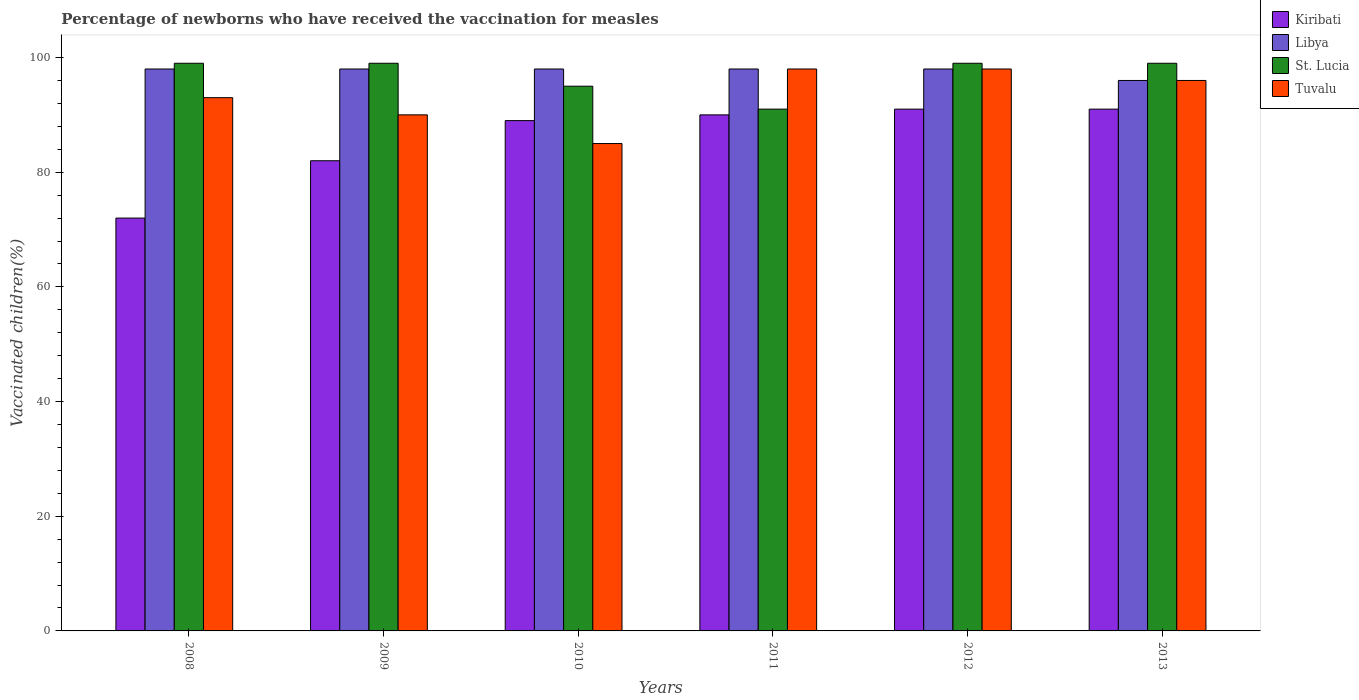How many groups of bars are there?
Provide a short and direct response. 6. How many bars are there on the 5th tick from the left?
Offer a terse response. 4. In how many cases, is the number of bars for a given year not equal to the number of legend labels?
Offer a very short reply. 0. What is the percentage of vaccinated children in St. Lucia in 2011?
Offer a very short reply. 91. Across all years, what is the maximum percentage of vaccinated children in Kiribati?
Provide a short and direct response. 91. In which year was the percentage of vaccinated children in Tuvalu maximum?
Offer a very short reply. 2011. In which year was the percentage of vaccinated children in Libya minimum?
Offer a terse response. 2013. What is the total percentage of vaccinated children in Libya in the graph?
Ensure brevity in your answer.  586. What is the difference between the percentage of vaccinated children in Tuvalu in 2010 and that in 2013?
Your answer should be compact. -11. What is the average percentage of vaccinated children in St. Lucia per year?
Your answer should be compact. 97. What is the ratio of the percentage of vaccinated children in Tuvalu in 2010 to that in 2011?
Keep it short and to the point. 0.87. Is the difference between the percentage of vaccinated children in Libya in 2009 and 2012 greater than the difference between the percentage of vaccinated children in Tuvalu in 2009 and 2012?
Ensure brevity in your answer.  Yes. Is the sum of the percentage of vaccinated children in Kiribati in 2010 and 2012 greater than the maximum percentage of vaccinated children in Libya across all years?
Provide a succinct answer. Yes. Is it the case that in every year, the sum of the percentage of vaccinated children in Tuvalu and percentage of vaccinated children in Kiribati is greater than the sum of percentage of vaccinated children in St. Lucia and percentage of vaccinated children in Libya?
Offer a terse response. No. What does the 3rd bar from the left in 2009 represents?
Your answer should be very brief. St. Lucia. What does the 4th bar from the right in 2011 represents?
Your answer should be very brief. Kiribati. How many bars are there?
Your answer should be very brief. 24. Are all the bars in the graph horizontal?
Make the answer very short. No. How many years are there in the graph?
Keep it short and to the point. 6. What is the difference between two consecutive major ticks on the Y-axis?
Your answer should be very brief. 20. Does the graph contain grids?
Make the answer very short. No. Where does the legend appear in the graph?
Your answer should be compact. Top right. How are the legend labels stacked?
Offer a very short reply. Vertical. What is the title of the graph?
Your answer should be compact. Percentage of newborns who have received the vaccination for measles. What is the label or title of the Y-axis?
Provide a succinct answer. Vaccinated children(%). What is the Vaccinated children(%) of Tuvalu in 2008?
Give a very brief answer. 93. What is the Vaccinated children(%) of Kiribati in 2010?
Offer a terse response. 89. What is the Vaccinated children(%) of St. Lucia in 2010?
Provide a succinct answer. 95. What is the Vaccinated children(%) of Tuvalu in 2010?
Keep it short and to the point. 85. What is the Vaccinated children(%) of Kiribati in 2011?
Make the answer very short. 90. What is the Vaccinated children(%) in Libya in 2011?
Your answer should be compact. 98. What is the Vaccinated children(%) in St. Lucia in 2011?
Offer a very short reply. 91. What is the Vaccinated children(%) in Tuvalu in 2011?
Make the answer very short. 98. What is the Vaccinated children(%) of Kiribati in 2012?
Your answer should be very brief. 91. What is the Vaccinated children(%) in St. Lucia in 2012?
Provide a short and direct response. 99. What is the Vaccinated children(%) in Kiribati in 2013?
Offer a very short reply. 91. What is the Vaccinated children(%) in Libya in 2013?
Your response must be concise. 96. What is the Vaccinated children(%) in Tuvalu in 2013?
Your answer should be very brief. 96. Across all years, what is the maximum Vaccinated children(%) of Kiribati?
Provide a short and direct response. 91. Across all years, what is the maximum Vaccinated children(%) in Libya?
Your answer should be very brief. 98. Across all years, what is the maximum Vaccinated children(%) in Tuvalu?
Keep it short and to the point. 98. Across all years, what is the minimum Vaccinated children(%) of Kiribati?
Offer a terse response. 72. Across all years, what is the minimum Vaccinated children(%) in Libya?
Offer a very short reply. 96. Across all years, what is the minimum Vaccinated children(%) of St. Lucia?
Ensure brevity in your answer.  91. Across all years, what is the minimum Vaccinated children(%) in Tuvalu?
Keep it short and to the point. 85. What is the total Vaccinated children(%) in Kiribati in the graph?
Provide a short and direct response. 515. What is the total Vaccinated children(%) of Libya in the graph?
Your response must be concise. 586. What is the total Vaccinated children(%) of St. Lucia in the graph?
Make the answer very short. 582. What is the total Vaccinated children(%) in Tuvalu in the graph?
Make the answer very short. 560. What is the difference between the Vaccinated children(%) in Libya in 2008 and that in 2009?
Provide a succinct answer. 0. What is the difference between the Vaccinated children(%) in St. Lucia in 2008 and that in 2009?
Offer a terse response. 0. What is the difference between the Vaccinated children(%) of Tuvalu in 2008 and that in 2009?
Offer a very short reply. 3. What is the difference between the Vaccinated children(%) of Kiribati in 2008 and that in 2010?
Give a very brief answer. -17. What is the difference between the Vaccinated children(%) in Tuvalu in 2008 and that in 2010?
Give a very brief answer. 8. What is the difference between the Vaccinated children(%) of Kiribati in 2008 and that in 2011?
Offer a very short reply. -18. What is the difference between the Vaccinated children(%) of St. Lucia in 2008 and that in 2011?
Your response must be concise. 8. What is the difference between the Vaccinated children(%) in Kiribati in 2008 and that in 2012?
Ensure brevity in your answer.  -19. What is the difference between the Vaccinated children(%) of Libya in 2008 and that in 2012?
Make the answer very short. 0. What is the difference between the Vaccinated children(%) of Tuvalu in 2008 and that in 2012?
Offer a terse response. -5. What is the difference between the Vaccinated children(%) in Kiribati in 2008 and that in 2013?
Offer a terse response. -19. What is the difference between the Vaccinated children(%) of Libya in 2008 and that in 2013?
Your answer should be compact. 2. What is the difference between the Vaccinated children(%) of St. Lucia in 2008 and that in 2013?
Offer a terse response. 0. What is the difference between the Vaccinated children(%) in Tuvalu in 2008 and that in 2013?
Offer a terse response. -3. What is the difference between the Vaccinated children(%) in St. Lucia in 2009 and that in 2010?
Make the answer very short. 4. What is the difference between the Vaccinated children(%) in St. Lucia in 2009 and that in 2011?
Offer a terse response. 8. What is the difference between the Vaccinated children(%) in Tuvalu in 2009 and that in 2011?
Keep it short and to the point. -8. What is the difference between the Vaccinated children(%) in Kiribati in 2009 and that in 2012?
Provide a short and direct response. -9. What is the difference between the Vaccinated children(%) of Tuvalu in 2009 and that in 2012?
Provide a succinct answer. -8. What is the difference between the Vaccinated children(%) in Tuvalu in 2009 and that in 2013?
Offer a very short reply. -6. What is the difference between the Vaccinated children(%) in Libya in 2010 and that in 2011?
Make the answer very short. 0. What is the difference between the Vaccinated children(%) in Tuvalu in 2010 and that in 2011?
Provide a short and direct response. -13. What is the difference between the Vaccinated children(%) of Kiribati in 2010 and that in 2012?
Give a very brief answer. -2. What is the difference between the Vaccinated children(%) of Tuvalu in 2010 and that in 2012?
Give a very brief answer. -13. What is the difference between the Vaccinated children(%) in St. Lucia in 2010 and that in 2013?
Provide a succinct answer. -4. What is the difference between the Vaccinated children(%) in Libya in 2011 and that in 2012?
Ensure brevity in your answer.  0. What is the difference between the Vaccinated children(%) of Tuvalu in 2011 and that in 2012?
Keep it short and to the point. 0. What is the difference between the Vaccinated children(%) of Kiribati in 2011 and that in 2013?
Make the answer very short. -1. What is the difference between the Vaccinated children(%) in Kiribati in 2008 and the Vaccinated children(%) in Libya in 2009?
Your response must be concise. -26. What is the difference between the Vaccinated children(%) in Libya in 2008 and the Vaccinated children(%) in St. Lucia in 2009?
Make the answer very short. -1. What is the difference between the Vaccinated children(%) in St. Lucia in 2008 and the Vaccinated children(%) in Tuvalu in 2009?
Ensure brevity in your answer.  9. What is the difference between the Vaccinated children(%) in Kiribati in 2008 and the Vaccinated children(%) in Libya in 2010?
Make the answer very short. -26. What is the difference between the Vaccinated children(%) in Kiribati in 2008 and the Vaccinated children(%) in St. Lucia in 2010?
Offer a terse response. -23. What is the difference between the Vaccinated children(%) of Libya in 2008 and the Vaccinated children(%) of Tuvalu in 2010?
Ensure brevity in your answer.  13. What is the difference between the Vaccinated children(%) in Kiribati in 2008 and the Vaccinated children(%) in Libya in 2011?
Offer a terse response. -26. What is the difference between the Vaccinated children(%) of Kiribati in 2008 and the Vaccinated children(%) of St. Lucia in 2011?
Provide a succinct answer. -19. What is the difference between the Vaccinated children(%) in St. Lucia in 2008 and the Vaccinated children(%) in Tuvalu in 2011?
Your response must be concise. 1. What is the difference between the Vaccinated children(%) in Kiribati in 2008 and the Vaccinated children(%) in Libya in 2012?
Make the answer very short. -26. What is the difference between the Vaccinated children(%) in Kiribati in 2008 and the Vaccinated children(%) in St. Lucia in 2012?
Provide a short and direct response. -27. What is the difference between the Vaccinated children(%) in Kiribati in 2008 and the Vaccinated children(%) in Tuvalu in 2012?
Provide a succinct answer. -26. What is the difference between the Vaccinated children(%) of Libya in 2008 and the Vaccinated children(%) of Tuvalu in 2012?
Provide a succinct answer. 0. What is the difference between the Vaccinated children(%) of Libya in 2008 and the Vaccinated children(%) of St. Lucia in 2013?
Offer a very short reply. -1. What is the difference between the Vaccinated children(%) of Libya in 2008 and the Vaccinated children(%) of Tuvalu in 2013?
Your answer should be compact. 2. What is the difference between the Vaccinated children(%) in Kiribati in 2009 and the Vaccinated children(%) in St. Lucia in 2010?
Offer a very short reply. -13. What is the difference between the Vaccinated children(%) in Kiribati in 2009 and the Vaccinated children(%) in Tuvalu in 2010?
Your answer should be very brief. -3. What is the difference between the Vaccinated children(%) of Libya in 2009 and the Vaccinated children(%) of Tuvalu in 2010?
Provide a succinct answer. 13. What is the difference between the Vaccinated children(%) in Kiribati in 2009 and the Vaccinated children(%) in Libya in 2011?
Offer a terse response. -16. What is the difference between the Vaccinated children(%) in Kiribati in 2009 and the Vaccinated children(%) in St. Lucia in 2011?
Keep it short and to the point. -9. What is the difference between the Vaccinated children(%) in Kiribati in 2009 and the Vaccinated children(%) in Tuvalu in 2011?
Ensure brevity in your answer.  -16. What is the difference between the Vaccinated children(%) of Kiribati in 2009 and the Vaccinated children(%) of Libya in 2012?
Make the answer very short. -16. What is the difference between the Vaccinated children(%) of Kiribati in 2009 and the Vaccinated children(%) of St. Lucia in 2012?
Offer a terse response. -17. What is the difference between the Vaccinated children(%) of Kiribati in 2009 and the Vaccinated children(%) of Tuvalu in 2012?
Give a very brief answer. -16. What is the difference between the Vaccinated children(%) of Libya in 2009 and the Vaccinated children(%) of St. Lucia in 2012?
Offer a very short reply. -1. What is the difference between the Vaccinated children(%) of Libya in 2009 and the Vaccinated children(%) of Tuvalu in 2012?
Provide a short and direct response. 0. What is the difference between the Vaccinated children(%) in St. Lucia in 2009 and the Vaccinated children(%) in Tuvalu in 2012?
Provide a succinct answer. 1. What is the difference between the Vaccinated children(%) in Kiribati in 2009 and the Vaccinated children(%) in St. Lucia in 2013?
Your answer should be very brief. -17. What is the difference between the Vaccinated children(%) in Kiribati in 2009 and the Vaccinated children(%) in Tuvalu in 2013?
Make the answer very short. -14. What is the difference between the Vaccinated children(%) in Libya in 2009 and the Vaccinated children(%) in St. Lucia in 2013?
Offer a very short reply. -1. What is the difference between the Vaccinated children(%) of Libya in 2009 and the Vaccinated children(%) of Tuvalu in 2013?
Give a very brief answer. 2. What is the difference between the Vaccinated children(%) in Kiribati in 2010 and the Vaccinated children(%) in St. Lucia in 2011?
Give a very brief answer. -2. What is the difference between the Vaccinated children(%) of Libya in 2010 and the Vaccinated children(%) of Tuvalu in 2011?
Provide a short and direct response. 0. What is the difference between the Vaccinated children(%) of Kiribati in 2010 and the Vaccinated children(%) of St. Lucia in 2012?
Offer a terse response. -10. What is the difference between the Vaccinated children(%) of Kiribati in 2010 and the Vaccinated children(%) of Libya in 2013?
Provide a short and direct response. -7. What is the difference between the Vaccinated children(%) in Kiribati in 2010 and the Vaccinated children(%) in St. Lucia in 2013?
Offer a terse response. -10. What is the difference between the Vaccinated children(%) of Libya in 2010 and the Vaccinated children(%) of St. Lucia in 2013?
Keep it short and to the point. -1. What is the difference between the Vaccinated children(%) of Libya in 2010 and the Vaccinated children(%) of Tuvalu in 2013?
Your answer should be very brief. 2. What is the difference between the Vaccinated children(%) of St. Lucia in 2010 and the Vaccinated children(%) of Tuvalu in 2013?
Provide a succinct answer. -1. What is the difference between the Vaccinated children(%) in Kiribati in 2011 and the Vaccinated children(%) in Tuvalu in 2012?
Your response must be concise. -8. What is the difference between the Vaccinated children(%) in Libya in 2011 and the Vaccinated children(%) in St. Lucia in 2012?
Provide a short and direct response. -1. What is the difference between the Vaccinated children(%) of Kiribati in 2011 and the Vaccinated children(%) of St. Lucia in 2013?
Keep it short and to the point. -9. What is the difference between the Vaccinated children(%) of Kiribati in 2011 and the Vaccinated children(%) of Tuvalu in 2013?
Keep it short and to the point. -6. What is the difference between the Vaccinated children(%) of Libya in 2011 and the Vaccinated children(%) of Tuvalu in 2013?
Your response must be concise. 2. What is the difference between the Vaccinated children(%) of St. Lucia in 2011 and the Vaccinated children(%) of Tuvalu in 2013?
Make the answer very short. -5. What is the difference between the Vaccinated children(%) in Kiribati in 2012 and the Vaccinated children(%) in Tuvalu in 2013?
Offer a terse response. -5. What is the difference between the Vaccinated children(%) of St. Lucia in 2012 and the Vaccinated children(%) of Tuvalu in 2013?
Your response must be concise. 3. What is the average Vaccinated children(%) of Kiribati per year?
Give a very brief answer. 85.83. What is the average Vaccinated children(%) of Libya per year?
Your answer should be compact. 97.67. What is the average Vaccinated children(%) of St. Lucia per year?
Offer a very short reply. 97. What is the average Vaccinated children(%) in Tuvalu per year?
Your answer should be compact. 93.33. In the year 2008, what is the difference between the Vaccinated children(%) of Kiribati and Vaccinated children(%) of Libya?
Provide a succinct answer. -26. In the year 2008, what is the difference between the Vaccinated children(%) of Libya and Vaccinated children(%) of Tuvalu?
Give a very brief answer. 5. In the year 2009, what is the difference between the Vaccinated children(%) of Kiribati and Vaccinated children(%) of St. Lucia?
Offer a very short reply. -17. In the year 2009, what is the difference between the Vaccinated children(%) of Libya and Vaccinated children(%) of Tuvalu?
Your answer should be compact. 8. In the year 2010, what is the difference between the Vaccinated children(%) of Kiribati and Vaccinated children(%) of Libya?
Keep it short and to the point. -9. In the year 2010, what is the difference between the Vaccinated children(%) in Kiribati and Vaccinated children(%) in St. Lucia?
Offer a very short reply. -6. In the year 2010, what is the difference between the Vaccinated children(%) in Libya and Vaccinated children(%) in St. Lucia?
Provide a succinct answer. 3. In the year 2010, what is the difference between the Vaccinated children(%) in Libya and Vaccinated children(%) in Tuvalu?
Ensure brevity in your answer.  13. In the year 2011, what is the difference between the Vaccinated children(%) of Kiribati and Vaccinated children(%) of St. Lucia?
Provide a short and direct response. -1. In the year 2011, what is the difference between the Vaccinated children(%) in Libya and Vaccinated children(%) in Tuvalu?
Offer a very short reply. 0. In the year 2012, what is the difference between the Vaccinated children(%) in St. Lucia and Vaccinated children(%) in Tuvalu?
Offer a terse response. 1. In the year 2013, what is the difference between the Vaccinated children(%) of Kiribati and Vaccinated children(%) of Libya?
Your answer should be very brief. -5. In the year 2013, what is the difference between the Vaccinated children(%) in Kiribati and Vaccinated children(%) in St. Lucia?
Make the answer very short. -8. In the year 2013, what is the difference between the Vaccinated children(%) in Kiribati and Vaccinated children(%) in Tuvalu?
Your response must be concise. -5. In the year 2013, what is the difference between the Vaccinated children(%) in St. Lucia and Vaccinated children(%) in Tuvalu?
Ensure brevity in your answer.  3. What is the ratio of the Vaccinated children(%) of Kiribati in 2008 to that in 2009?
Provide a succinct answer. 0.88. What is the ratio of the Vaccinated children(%) of Kiribati in 2008 to that in 2010?
Your answer should be compact. 0.81. What is the ratio of the Vaccinated children(%) in Libya in 2008 to that in 2010?
Your answer should be compact. 1. What is the ratio of the Vaccinated children(%) of St. Lucia in 2008 to that in 2010?
Offer a terse response. 1.04. What is the ratio of the Vaccinated children(%) in Tuvalu in 2008 to that in 2010?
Keep it short and to the point. 1.09. What is the ratio of the Vaccinated children(%) in Kiribati in 2008 to that in 2011?
Your answer should be very brief. 0.8. What is the ratio of the Vaccinated children(%) in St. Lucia in 2008 to that in 2011?
Ensure brevity in your answer.  1.09. What is the ratio of the Vaccinated children(%) of Tuvalu in 2008 to that in 2011?
Make the answer very short. 0.95. What is the ratio of the Vaccinated children(%) in Kiribati in 2008 to that in 2012?
Your response must be concise. 0.79. What is the ratio of the Vaccinated children(%) in Libya in 2008 to that in 2012?
Provide a succinct answer. 1. What is the ratio of the Vaccinated children(%) of St. Lucia in 2008 to that in 2012?
Make the answer very short. 1. What is the ratio of the Vaccinated children(%) in Tuvalu in 2008 to that in 2012?
Provide a short and direct response. 0.95. What is the ratio of the Vaccinated children(%) of Kiribati in 2008 to that in 2013?
Your response must be concise. 0.79. What is the ratio of the Vaccinated children(%) of Libya in 2008 to that in 2013?
Your answer should be compact. 1.02. What is the ratio of the Vaccinated children(%) of Tuvalu in 2008 to that in 2013?
Offer a very short reply. 0.97. What is the ratio of the Vaccinated children(%) in Kiribati in 2009 to that in 2010?
Your answer should be compact. 0.92. What is the ratio of the Vaccinated children(%) in St. Lucia in 2009 to that in 2010?
Make the answer very short. 1.04. What is the ratio of the Vaccinated children(%) of Tuvalu in 2009 to that in 2010?
Offer a very short reply. 1.06. What is the ratio of the Vaccinated children(%) of Kiribati in 2009 to that in 2011?
Keep it short and to the point. 0.91. What is the ratio of the Vaccinated children(%) in Libya in 2009 to that in 2011?
Provide a succinct answer. 1. What is the ratio of the Vaccinated children(%) in St. Lucia in 2009 to that in 2011?
Offer a terse response. 1.09. What is the ratio of the Vaccinated children(%) of Tuvalu in 2009 to that in 2011?
Make the answer very short. 0.92. What is the ratio of the Vaccinated children(%) of Kiribati in 2009 to that in 2012?
Keep it short and to the point. 0.9. What is the ratio of the Vaccinated children(%) of St. Lucia in 2009 to that in 2012?
Make the answer very short. 1. What is the ratio of the Vaccinated children(%) in Tuvalu in 2009 to that in 2012?
Ensure brevity in your answer.  0.92. What is the ratio of the Vaccinated children(%) of Kiribati in 2009 to that in 2013?
Provide a short and direct response. 0.9. What is the ratio of the Vaccinated children(%) of Libya in 2009 to that in 2013?
Keep it short and to the point. 1.02. What is the ratio of the Vaccinated children(%) in Tuvalu in 2009 to that in 2013?
Make the answer very short. 0.94. What is the ratio of the Vaccinated children(%) in Kiribati in 2010 to that in 2011?
Give a very brief answer. 0.99. What is the ratio of the Vaccinated children(%) in St. Lucia in 2010 to that in 2011?
Offer a very short reply. 1.04. What is the ratio of the Vaccinated children(%) of Tuvalu in 2010 to that in 2011?
Give a very brief answer. 0.87. What is the ratio of the Vaccinated children(%) of Libya in 2010 to that in 2012?
Your answer should be very brief. 1. What is the ratio of the Vaccinated children(%) of St. Lucia in 2010 to that in 2012?
Ensure brevity in your answer.  0.96. What is the ratio of the Vaccinated children(%) of Tuvalu in 2010 to that in 2012?
Provide a short and direct response. 0.87. What is the ratio of the Vaccinated children(%) in Kiribati in 2010 to that in 2013?
Your answer should be compact. 0.98. What is the ratio of the Vaccinated children(%) in Libya in 2010 to that in 2013?
Offer a terse response. 1.02. What is the ratio of the Vaccinated children(%) in St. Lucia in 2010 to that in 2013?
Keep it short and to the point. 0.96. What is the ratio of the Vaccinated children(%) in Tuvalu in 2010 to that in 2013?
Keep it short and to the point. 0.89. What is the ratio of the Vaccinated children(%) of St. Lucia in 2011 to that in 2012?
Offer a terse response. 0.92. What is the ratio of the Vaccinated children(%) in Kiribati in 2011 to that in 2013?
Your answer should be very brief. 0.99. What is the ratio of the Vaccinated children(%) of Libya in 2011 to that in 2013?
Make the answer very short. 1.02. What is the ratio of the Vaccinated children(%) of St. Lucia in 2011 to that in 2013?
Ensure brevity in your answer.  0.92. What is the ratio of the Vaccinated children(%) in Tuvalu in 2011 to that in 2013?
Provide a succinct answer. 1.02. What is the ratio of the Vaccinated children(%) of Libya in 2012 to that in 2013?
Give a very brief answer. 1.02. What is the ratio of the Vaccinated children(%) in Tuvalu in 2012 to that in 2013?
Your answer should be very brief. 1.02. What is the difference between the highest and the second highest Vaccinated children(%) of Kiribati?
Offer a terse response. 0. What is the difference between the highest and the second highest Vaccinated children(%) in Tuvalu?
Your answer should be compact. 0. What is the difference between the highest and the lowest Vaccinated children(%) in Kiribati?
Give a very brief answer. 19. What is the difference between the highest and the lowest Vaccinated children(%) of Libya?
Ensure brevity in your answer.  2. What is the difference between the highest and the lowest Vaccinated children(%) of St. Lucia?
Make the answer very short. 8. What is the difference between the highest and the lowest Vaccinated children(%) in Tuvalu?
Keep it short and to the point. 13. 